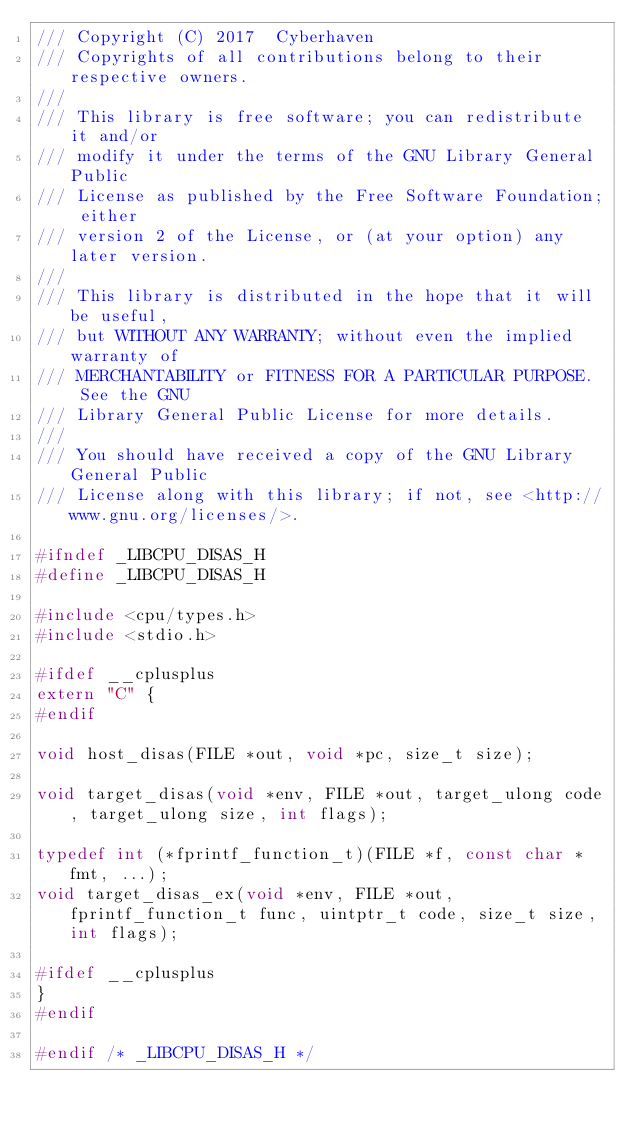<code> <loc_0><loc_0><loc_500><loc_500><_C_>/// Copyright (C) 2017  Cyberhaven
/// Copyrights of all contributions belong to their respective owners.
///
/// This library is free software; you can redistribute it and/or
/// modify it under the terms of the GNU Library General Public
/// License as published by the Free Software Foundation; either
/// version 2 of the License, or (at your option) any later version.
///
/// This library is distributed in the hope that it will be useful,
/// but WITHOUT ANY WARRANTY; without even the implied warranty of
/// MERCHANTABILITY or FITNESS FOR A PARTICULAR PURPOSE.  See the GNU
/// Library General Public License for more details.
///
/// You should have received a copy of the GNU Library General Public
/// License along with this library; if not, see <http://www.gnu.org/licenses/>.

#ifndef _LIBCPU_DISAS_H
#define _LIBCPU_DISAS_H

#include <cpu/types.h>
#include <stdio.h>

#ifdef __cplusplus
extern "C" {
#endif

void host_disas(FILE *out, void *pc, size_t size);

void target_disas(void *env, FILE *out, target_ulong code, target_ulong size, int flags);

typedef int (*fprintf_function_t)(FILE *f, const char *fmt, ...);
void target_disas_ex(void *env, FILE *out, fprintf_function_t func, uintptr_t code, size_t size, int flags);

#ifdef __cplusplus
}
#endif

#endif /* _LIBCPU_DISAS_H */
</code> 